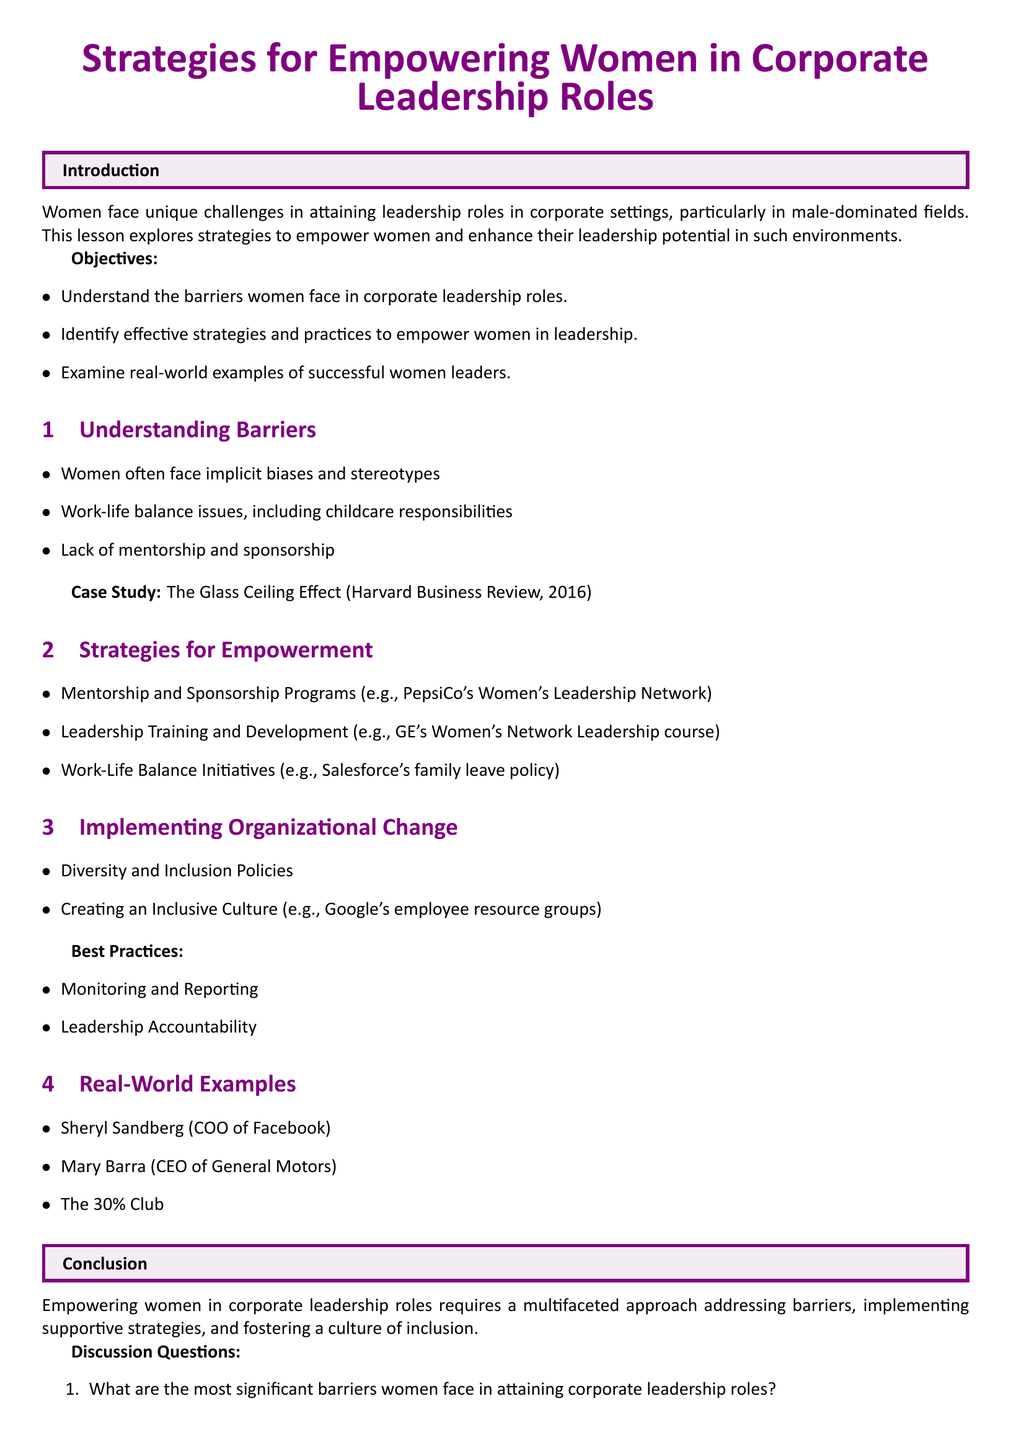What are the unique challenges women face in corporate settings? The document states that women face unique challenges in attaining leadership roles, particularly in male-dominated fields.
Answer: Unique challenges What is one of the most significant barriers women face in leadership roles? According to the document, implicit biases and stereotypes are significant barriers for women.
Answer: Implicit biases Which corporation is mentioned as having a Women's Leadership Network? The document cites PepsiCo as having a Women's Leadership Network for mentoring.
Answer: PepsiCo What is an example of a work-life balance initiative? The document references Salesforce's family leave policy as an example of a work-life balance initiative.
Answer: Salesforce's family leave policy Who is the CEO of General Motors? The document lists Mary Barra as the CEO of General Motors.
Answer: Mary Barra What percentage does the 30% Club aim to have women in leadership roles? While the exact percentage is not indicated in the document, it is implied to be 30%.
Answer: 30% What type of organizational change does the document suggest? The document suggests implementing diversity and inclusion policies as a type of organizational change.
Answer: Diversity and inclusion policies What is the purpose of monitoring and reporting in corporate leadership? The document lists monitoring and reporting as best practices to ensure accountability in leadership roles.
Answer: Accountability Which book is suggested for further reading on women's leadership? The document suggests "Lean In: Women, Work, and the Will to Lead" by Sheryl Sandberg for further reading.
Answer: Lean In: Women, Work, and the Will to Lead 